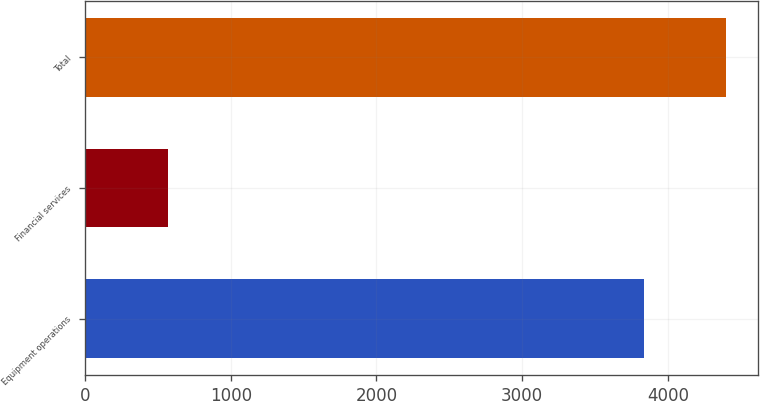<chart> <loc_0><loc_0><loc_500><loc_500><bar_chart><fcel>Equipment operations<fcel>Financial services<fcel>Total<nl><fcel>3836<fcel>566<fcel>4402<nl></chart> 